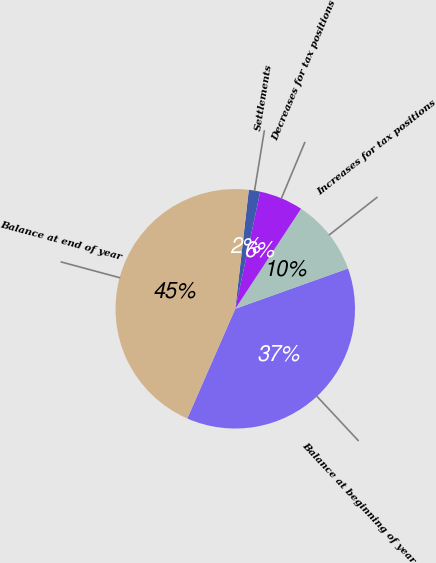<chart> <loc_0><loc_0><loc_500><loc_500><pie_chart><fcel>Balance at beginning of year<fcel>Increases for tax positions<fcel>Decreases for tax positions<fcel>Settlements<fcel>Balance at end of year<nl><fcel>37.02%<fcel>10.28%<fcel>5.91%<fcel>1.54%<fcel>45.24%<nl></chart> 